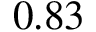Convert formula to latex. <formula><loc_0><loc_0><loc_500><loc_500>0 . 8 3</formula> 